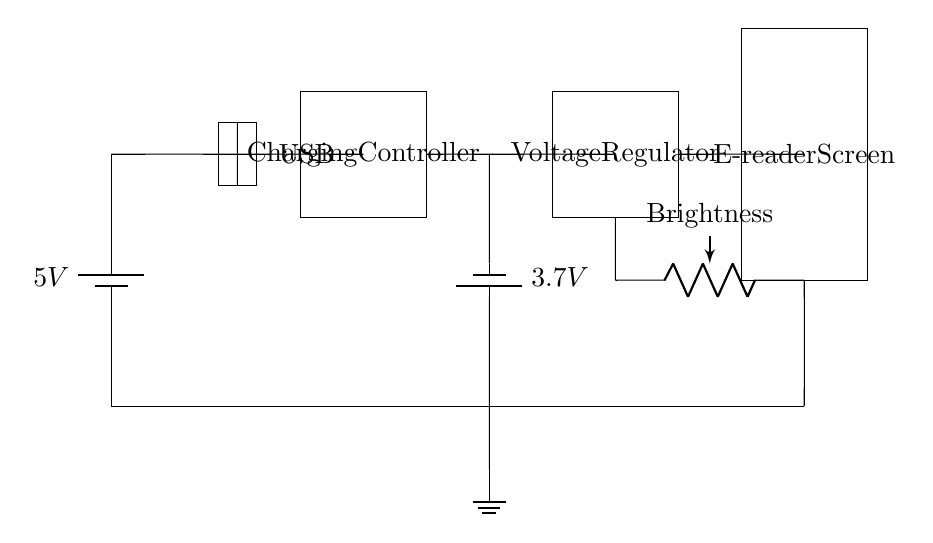What is the input voltage for the charging circuit? The input voltage is 5V, which comes from the battery in the circuit indicated at the power source.
Answer: 5V What is the output voltage of the battery used in this circuit? The output voltage is 3.7V, which is the potential difference indicated on the battery component in the diagram.
Answer: 3.7V What component is responsible for adjusting the brightness of the e-reader? The component responsible for adjusting brightness is the potentiometer, which is labeled as "Brightness" in the circuit.
Answer: Potentiometer Which component regulates the voltage before it reaches the e-reader? The voltage regulator is the component that regulates the voltage, indicated in the circuit diagram as the box labeled "Voltage Regulator."
Answer: Voltage Regulator What is the purpose of the charging controller in this circuit? The charging controller is responsible for managing the charging process of the battery, ensuring it charges safely and efficiently.
Answer: Charging Controller How many main components are there in the charging circuit? There are five main components: battery, charging controller, voltage regulator, potentiometer, and the e-reader screen.
Answer: Five What type of connection is used for the USB interface in the circuit? The connection used for the USB interface is a short connection, as indicated by the straight lines connecting the USB to the charging controller.
Answer: Short connection 